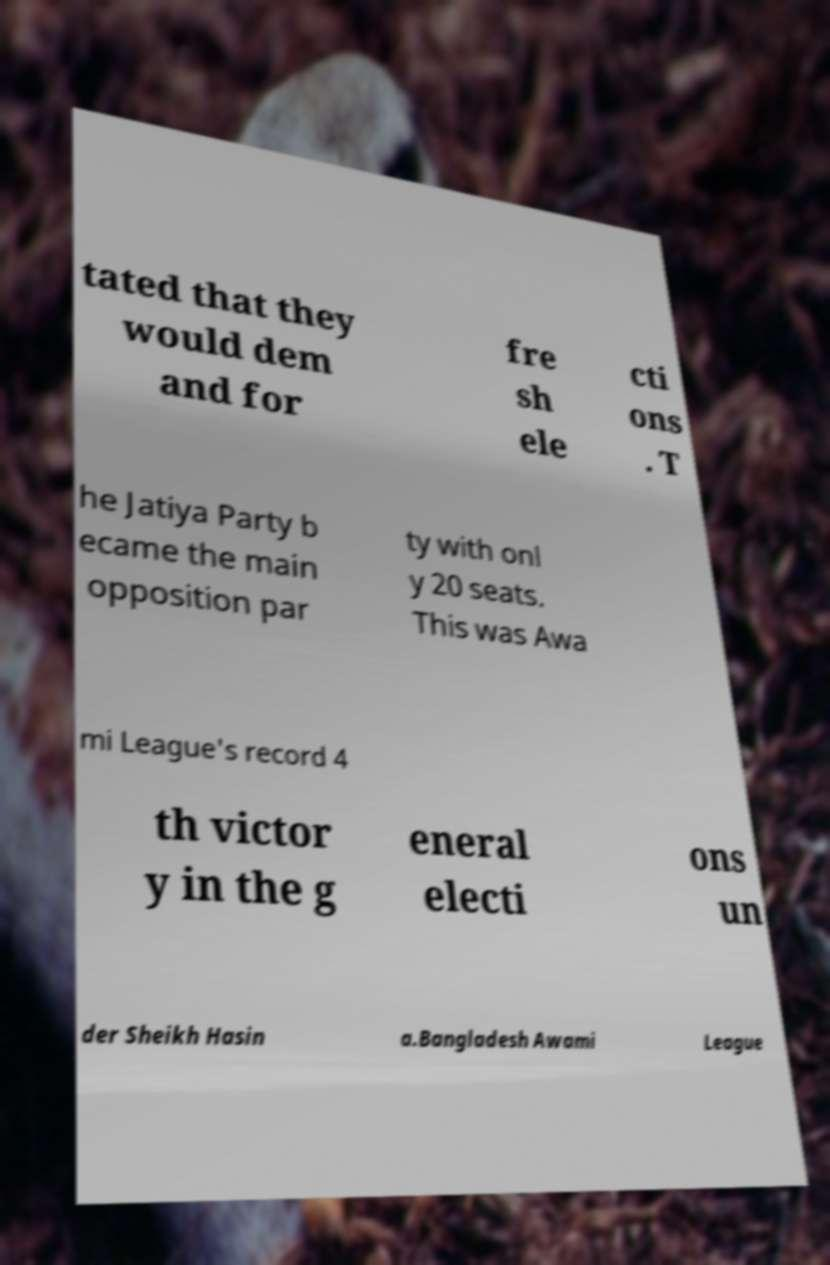Can you read and provide the text displayed in the image?This photo seems to have some interesting text. Can you extract and type it out for me? tated that they would dem and for fre sh ele cti ons . T he Jatiya Party b ecame the main opposition par ty with onl y 20 seats. This was Awa mi League's record 4 th victor y in the g eneral electi ons un der Sheikh Hasin a.Bangladesh Awami League 